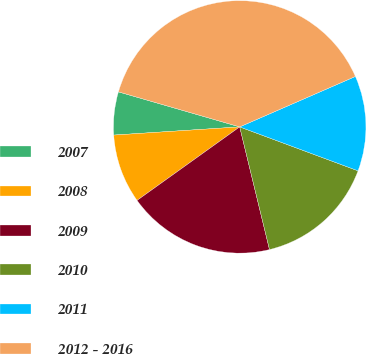Convert chart. <chart><loc_0><loc_0><loc_500><loc_500><pie_chart><fcel>2007<fcel>2008<fcel>2009<fcel>2010<fcel>2011<fcel>2012 - 2016<nl><fcel>5.51%<fcel>8.86%<fcel>18.9%<fcel>15.55%<fcel>12.2%<fcel>38.98%<nl></chart> 